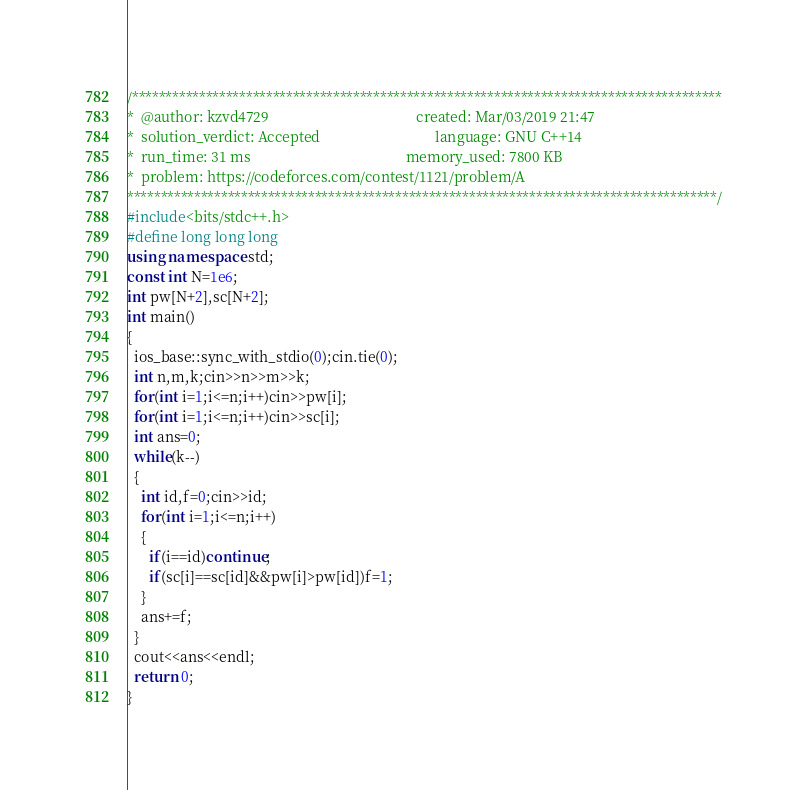<code> <loc_0><loc_0><loc_500><loc_500><_C++_>/****************************************************************************************
*  @author: kzvd4729                                         created: Mar/03/2019 21:47                        
*  solution_verdict: Accepted                                language: GNU C++14                               
*  run_time: 31 ms                                           memory_used: 7800 KB                              
*  problem: https://codeforces.com/contest/1121/problem/A
****************************************************************************************/
#include<bits/stdc++.h>
#define long long long
using namespace std;
const int N=1e6;
int pw[N+2],sc[N+2];
int main()
{
  ios_base::sync_with_stdio(0);cin.tie(0);
  int n,m,k;cin>>n>>m>>k;
  for(int i=1;i<=n;i++)cin>>pw[i];
  for(int i=1;i<=n;i++)cin>>sc[i];
  int ans=0;
  while(k--)
  {
    int id,f=0;cin>>id;
    for(int i=1;i<=n;i++)
    {
      if(i==id)continue;
      if(sc[i]==sc[id]&&pw[i]>pw[id])f=1;
    }
    ans+=f;
  }
  cout<<ans<<endl;
  return 0;
}</code> 